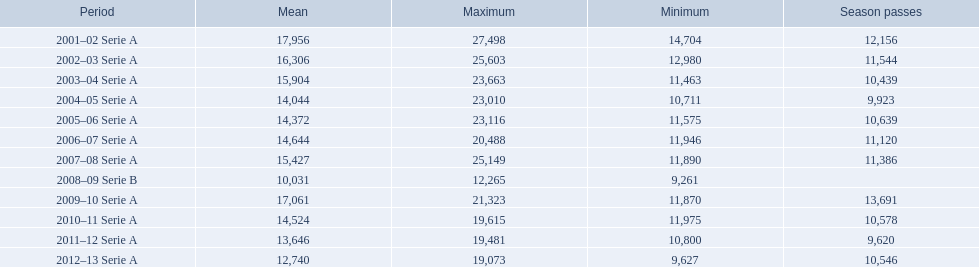When were all of the seasons? 2001–02 Serie A, 2002–03 Serie A, 2003–04 Serie A, 2004–05 Serie A, 2005–06 Serie A, 2006–07 Serie A, 2007–08 Serie A, 2008–09 Serie B, 2009–10 Serie A, 2010–11 Serie A, 2011–12 Serie A, 2012–13 Serie A. How many tickets were sold? 12,156, 11,544, 10,439, 9,923, 10,639, 11,120, 11,386, , 13,691, 10,578, 9,620, 10,546. What about just during the 2007 season? 11,386. 